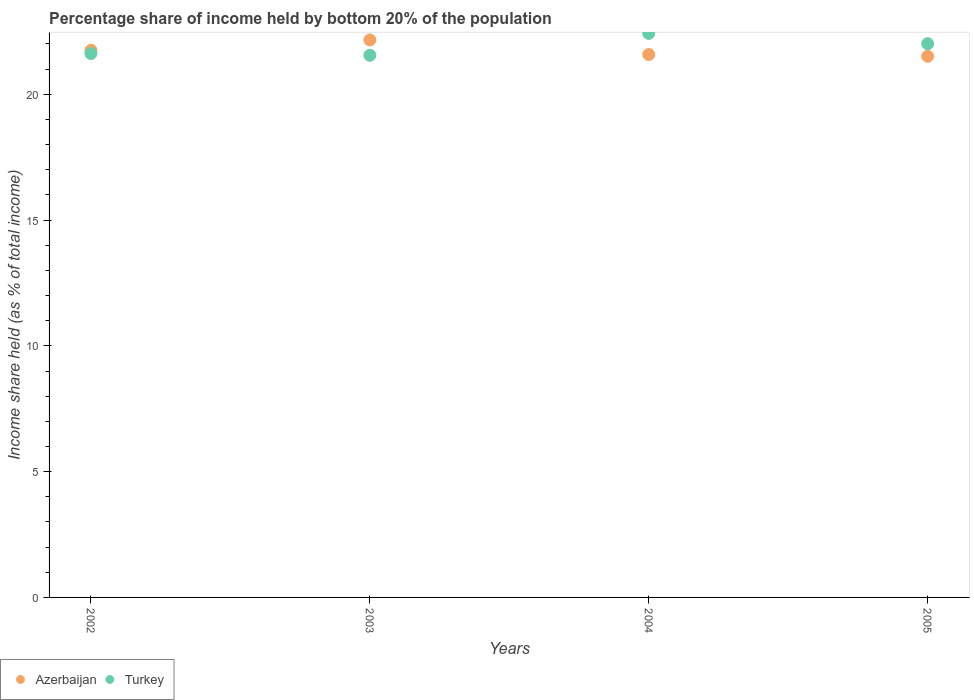How many different coloured dotlines are there?
Offer a terse response. 2. Is the number of dotlines equal to the number of legend labels?
Keep it short and to the point. Yes. What is the share of income held by bottom 20% of the population in Turkey in 2005?
Give a very brief answer. 22.01. Across all years, what is the maximum share of income held by bottom 20% of the population in Turkey?
Your response must be concise. 22.42. Across all years, what is the minimum share of income held by bottom 20% of the population in Turkey?
Your answer should be very brief. 21.55. In which year was the share of income held by bottom 20% of the population in Azerbaijan minimum?
Your answer should be compact. 2005. What is the total share of income held by bottom 20% of the population in Turkey in the graph?
Ensure brevity in your answer.  87.6. What is the difference between the share of income held by bottom 20% of the population in Azerbaijan in 2004 and that in 2005?
Make the answer very short. 0.07. What is the difference between the share of income held by bottom 20% of the population in Turkey in 2003 and the share of income held by bottom 20% of the population in Azerbaijan in 2005?
Your response must be concise. 0.04. What is the average share of income held by bottom 20% of the population in Turkey per year?
Provide a succinct answer. 21.9. In the year 2003, what is the difference between the share of income held by bottom 20% of the population in Azerbaijan and share of income held by bottom 20% of the population in Turkey?
Your response must be concise. 0.61. What is the ratio of the share of income held by bottom 20% of the population in Turkey in 2002 to that in 2003?
Offer a terse response. 1. Is the difference between the share of income held by bottom 20% of the population in Azerbaijan in 2002 and 2003 greater than the difference between the share of income held by bottom 20% of the population in Turkey in 2002 and 2003?
Your answer should be compact. No. What is the difference between the highest and the second highest share of income held by bottom 20% of the population in Azerbaijan?
Your answer should be compact. 0.41. What is the difference between the highest and the lowest share of income held by bottom 20% of the population in Turkey?
Keep it short and to the point. 0.87. Does the share of income held by bottom 20% of the population in Azerbaijan monotonically increase over the years?
Ensure brevity in your answer.  No. Is the share of income held by bottom 20% of the population in Turkey strictly greater than the share of income held by bottom 20% of the population in Azerbaijan over the years?
Offer a terse response. No. How many dotlines are there?
Ensure brevity in your answer.  2. How many years are there in the graph?
Keep it short and to the point. 4. Are the values on the major ticks of Y-axis written in scientific E-notation?
Make the answer very short. No. Where does the legend appear in the graph?
Your answer should be compact. Bottom left. How many legend labels are there?
Make the answer very short. 2. How are the legend labels stacked?
Keep it short and to the point. Horizontal. What is the title of the graph?
Offer a terse response. Percentage share of income held by bottom 20% of the population. Does "Myanmar" appear as one of the legend labels in the graph?
Your answer should be compact. No. What is the label or title of the Y-axis?
Provide a succinct answer. Income share held (as % of total income). What is the Income share held (as % of total income) of Azerbaijan in 2002?
Offer a very short reply. 21.75. What is the Income share held (as % of total income) in Turkey in 2002?
Ensure brevity in your answer.  21.62. What is the Income share held (as % of total income) in Azerbaijan in 2003?
Offer a very short reply. 22.16. What is the Income share held (as % of total income) of Turkey in 2003?
Offer a very short reply. 21.55. What is the Income share held (as % of total income) of Azerbaijan in 2004?
Your response must be concise. 21.58. What is the Income share held (as % of total income) of Turkey in 2004?
Your answer should be very brief. 22.42. What is the Income share held (as % of total income) of Azerbaijan in 2005?
Your answer should be compact. 21.51. What is the Income share held (as % of total income) of Turkey in 2005?
Offer a terse response. 22.01. Across all years, what is the maximum Income share held (as % of total income) of Azerbaijan?
Make the answer very short. 22.16. Across all years, what is the maximum Income share held (as % of total income) of Turkey?
Give a very brief answer. 22.42. Across all years, what is the minimum Income share held (as % of total income) in Azerbaijan?
Your response must be concise. 21.51. Across all years, what is the minimum Income share held (as % of total income) in Turkey?
Your answer should be compact. 21.55. What is the total Income share held (as % of total income) in Azerbaijan in the graph?
Provide a succinct answer. 87. What is the total Income share held (as % of total income) in Turkey in the graph?
Give a very brief answer. 87.6. What is the difference between the Income share held (as % of total income) in Azerbaijan in 2002 and that in 2003?
Your response must be concise. -0.41. What is the difference between the Income share held (as % of total income) in Turkey in 2002 and that in 2003?
Offer a terse response. 0.07. What is the difference between the Income share held (as % of total income) of Azerbaijan in 2002 and that in 2004?
Give a very brief answer. 0.17. What is the difference between the Income share held (as % of total income) of Turkey in 2002 and that in 2004?
Provide a short and direct response. -0.8. What is the difference between the Income share held (as % of total income) in Azerbaijan in 2002 and that in 2005?
Offer a terse response. 0.24. What is the difference between the Income share held (as % of total income) in Turkey in 2002 and that in 2005?
Your answer should be very brief. -0.39. What is the difference between the Income share held (as % of total income) in Azerbaijan in 2003 and that in 2004?
Keep it short and to the point. 0.58. What is the difference between the Income share held (as % of total income) in Turkey in 2003 and that in 2004?
Offer a very short reply. -0.87. What is the difference between the Income share held (as % of total income) of Azerbaijan in 2003 and that in 2005?
Offer a very short reply. 0.65. What is the difference between the Income share held (as % of total income) in Turkey in 2003 and that in 2005?
Make the answer very short. -0.46. What is the difference between the Income share held (as % of total income) in Azerbaijan in 2004 and that in 2005?
Your answer should be compact. 0.07. What is the difference between the Income share held (as % of total income) in Turkey in 2004 and that in 2005?
Your response must be concise. 0.41. What is the difference between the Income share held (as % of total income) of Azerbaijan in 2002 and the Income share held (as % of total income) of Turkey in 2004?
Offer a very short reply. -0.67. What is the difference between the Income share held (as % of total income) of Azerbaijan in 2002 and the Income share held (as % of total income) of Turkey in 2005?
Make the answer very short. -0.26. What is the difference between the Income share held (as % of total income) of Azerbaijan in 2003 and the Income share held (as % of total income) of Turkey in 2004?
Keep it short and to the point. -0.26. What is the difference between the Income share held (as % of total income) in Azerbaijan in 2003 and the Income share held (as % of total income) in Turkey in 2005?
Ensure brevity in your answer.  0.15. What is the difference between the Income share held (as % of total income) in Azerbaijan in 2004 and the Income share held (as % of total income) in Turkey in 2005?
Your response must be concise. -0.43. What is the average Income share held (as % of total income) in Azerbaijan per year?
Make the answer very short. 21.75. What is the average Income share held (as % of total income) of Turkey per year?
Make the answer very short. 21.9. In the year 2002, what is the difference between the Income share held (as % of total income) of Azerbaijan and Income share held (as % of total income) of Turkey?
Your answer should be compact. 0.13. In the year 2003, what is the difference between the Income share held (as % of total income) in Azerbaijan and Income share held (as % of total income) in Turkey?
Provide a short and direct response. 0.61. In the year 2004, what is the difference between the Income share held (as % of total income) of Azerbaijan and Income share held (as % of total income) of Turkey?
Offer a terse response. -0.84. In the year 2005, what is the difference between the Income share held (as % of total income) in Azerbaijan and Income share held (as % of total income) in Turkey?
Your answer should be very brief. -0.5. What is the ratio of the Income share held (as % of total income) in Azerbaijan in 2002 to that in 2003?
Provide a succinct answer. 0.98. What is the ratio of the Income share held (as % of total income) of Azerbaijan in 2002 to that in 2004?
Offer a terse response. 1.01. What is the ratio of the Income share held (as % of total income) in Azerbaijan in 2002 to that in 2005?
Give a very brief answer. 1.01. What is the ratio of the Income share held (as % of total income) of Turkey in 2002 to that in 2005?
Offer a terse response. 0.98. What is the ratio of the Income share held (as % of total income) of Azerbaijan in 2003 to that in 2004?
Make the answer very short. 1.03. What is the ratio of the Income share held (as % of total income) of Turkey in 2003 to that in 2004?
Your response must be concise. 0.96. What is the ratio of the Income share held (as % of total income) of Azerbaijan in 2003 to that in 2005?
Provide a succinct answer. 1.03. What is the ratio of the Income share held (as % of total income) in Turkey in 2003 to that in 2005?
Offer a terse response. 0.98. What is the ratio of the Income share held (as % of total income) in Azerbaijan in 2004 to that in 2005?
Offer a very short reply. 1. What is the ratio of the Income share held (as % of total income) in Turkey in 2004 to that in 2005?
Your answer should be very brief. 1.02. What is the difference between the highest and the second highest Income share held (as % of total income) in Azerbaijan?
Offer a very short reply. 0.41. What is the difference between the highest and the second highest Income share held (as % of total income) of Turkey?
Offer a very short reply. 0.41. What is the difference between the highest and the lowest Income share held (as % of total income) of Azerbaijan?
Provide a succinct answer. 0.65. What is the difference between the highest and the lowest Income share held (as % of total income) in Turkey?
Ensure brevity in your answer.  0.87. 